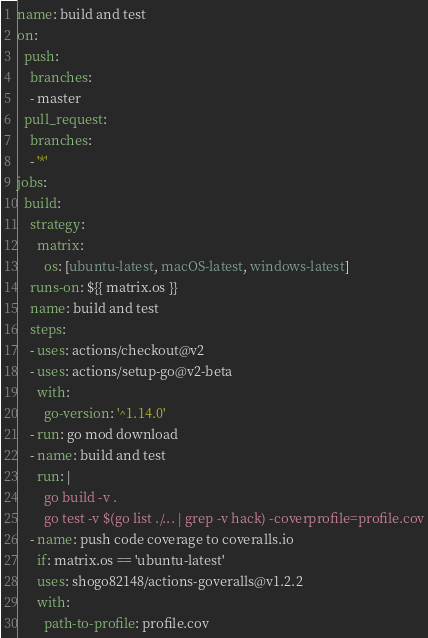Convert code to text. <code><loc_0><loc_0><loc_500><loc_500><_YAML_>name: build and test
on:
  push:
    branches:
    - master
  pull_request:
    branches:
    - '*'
jobs:
  build:
    strategy:
      matrix:
        os: [ubuntu-latest, macOS-latest, windows-latest]
    runs-on: ${{ matrix.os }}
    name: build and test
    steps:
    - uses: actions/checkout@v2
    - uses: actions/setup-go@v2-beta
      with:
        go-version: '^1.14.0'
    - run: go mod download
    - name: build and test
      run: |
        go build -v .
        go test -v $(go list ./... | grep -v hack) -coverprofile=profile.cov
    - name: push code coverage to coveralls.io
      if: matrix.os == 'ubuntu-latest'
      uses: shogo82148/actions-goveralls@v1.2.2
      with:
        path-to-profile: profile.cov
</code> 